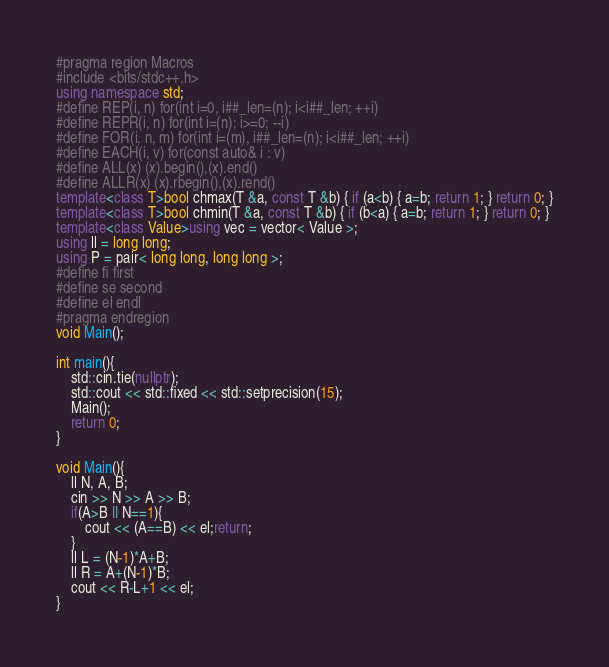<code> <loc_0><loc_0><loc_500><loc_500><_C++_>#pragma region Macros
#include <bits/stdc++.h>
using namespace std;
#define REP(i, n) for(int i=0, i##_len=(n); i<i##_len; ++i)
#define REPR(i, n) for(int i=(n); i>=0; --i)
#define FOR(i, n, m) for(int i=(m), i##_len=(n); i<i##_len; ++i)
#define EACH(i, v) for(const auto& i : v)
#define ALL(x) (x).begin(),(x).end()
#define ALLR(x) (x).rbegin(),(x).rend()
template<class T>bool chmax(T &a, const T &b) { if (a<b) { a=b; return 1; } return 0; }
template<class T>bool chmin(T &a, const T &b) { if (b<a) { a=b; return 1; } return 0; }
template<class Value>using vec = vector< Value >;
using ll = long long;
using P = pair< long long, long long >;
#define fi first
#define se second
#define el endl
#pragma endregion
void Main();

int main(){
    std::cin.tie(nullptr);
    std::cout << std::fixed << std::setprecision(15);
    Main();
    return 0;
}

void Main(){
    ll N, A, B;
    cin >> N >> A >> B;
    if(A>B || N==1){
        cout << (A==B) << el;return;
    }
    ll L = (N-1)*A+B;
    ll R = A+(N-1)*B;
    cout << R-L+1 << el;
}

</code> 